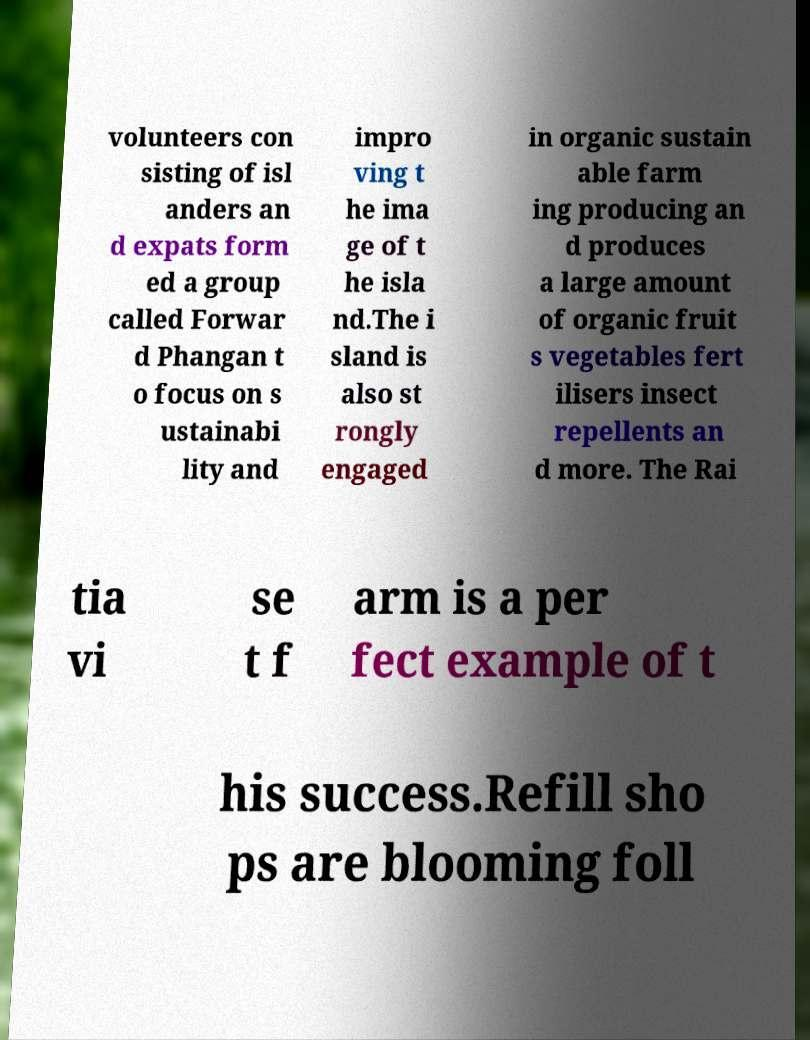For documentation purposes, I need the text within this image transcribed. Could you provide that? volunteers con sisting of isl anders an d expats form ed a group called Forwar d Phangan t o focus on s ustainabi lity and impro ving t he ima ge of t he isla nd.The i sland is also st rongly engaged in organic sustain able farm ing producing an d produces a large amount of organic fruit s vegetables fert ilisers insect repellents an d more. The Rai tia vi se t f arm is a per fect example of t his success.Refill sho ps are blooming foll 